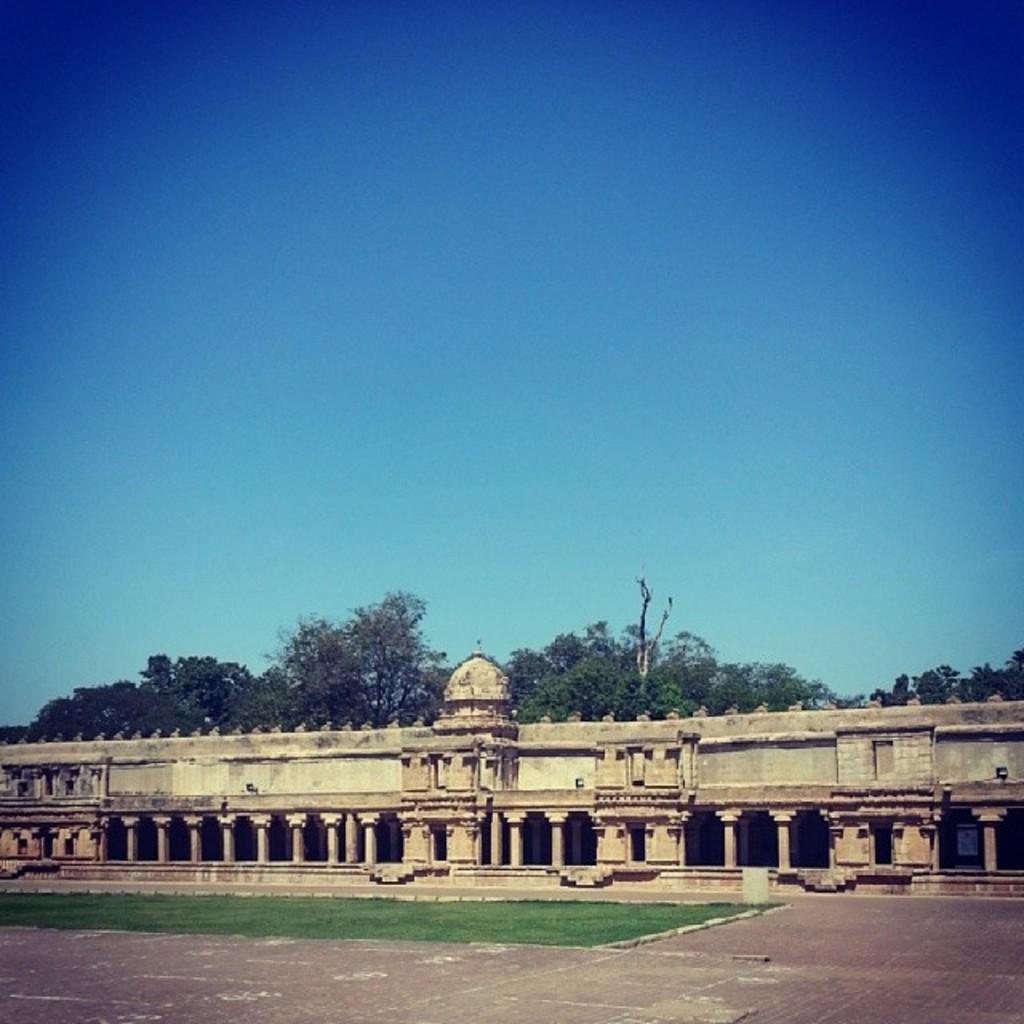Please provide a concise description of this image. In this image I can see the ground, some grass and the building. In the background I can few trees and the sky. 